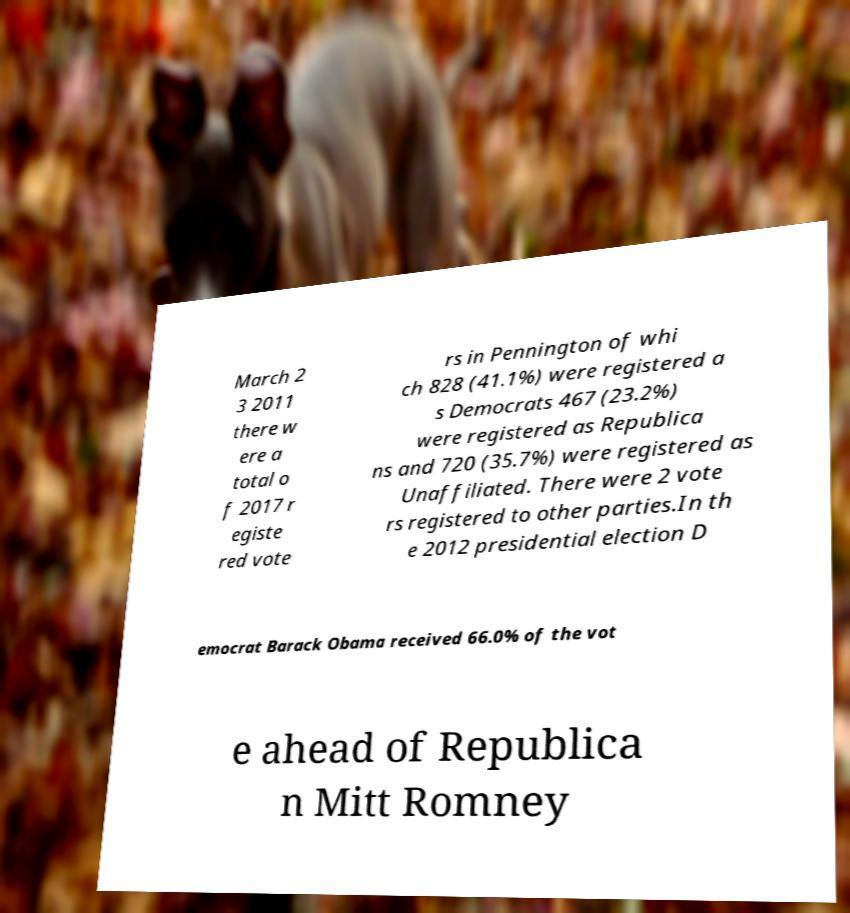Can you read and provide the text displayed in the image?This photo seems to have some interesting text. Can you extract and type it out for me? March 2 3 2011 there w ere a total o f 2017 r egiste red vote rs in Pennington of whi ch 828 (41.1%) were registered a s Democrats 467 (23.2%) were registered as Republica ns and 720 (35.7%) were registered as Unaffiliated. There were 2 vote rs registered to other parties.In th e 2012 presidential election D emocrat Barack Obama received 66.0% of the vot e ahead of Republica n Mitt Romney 